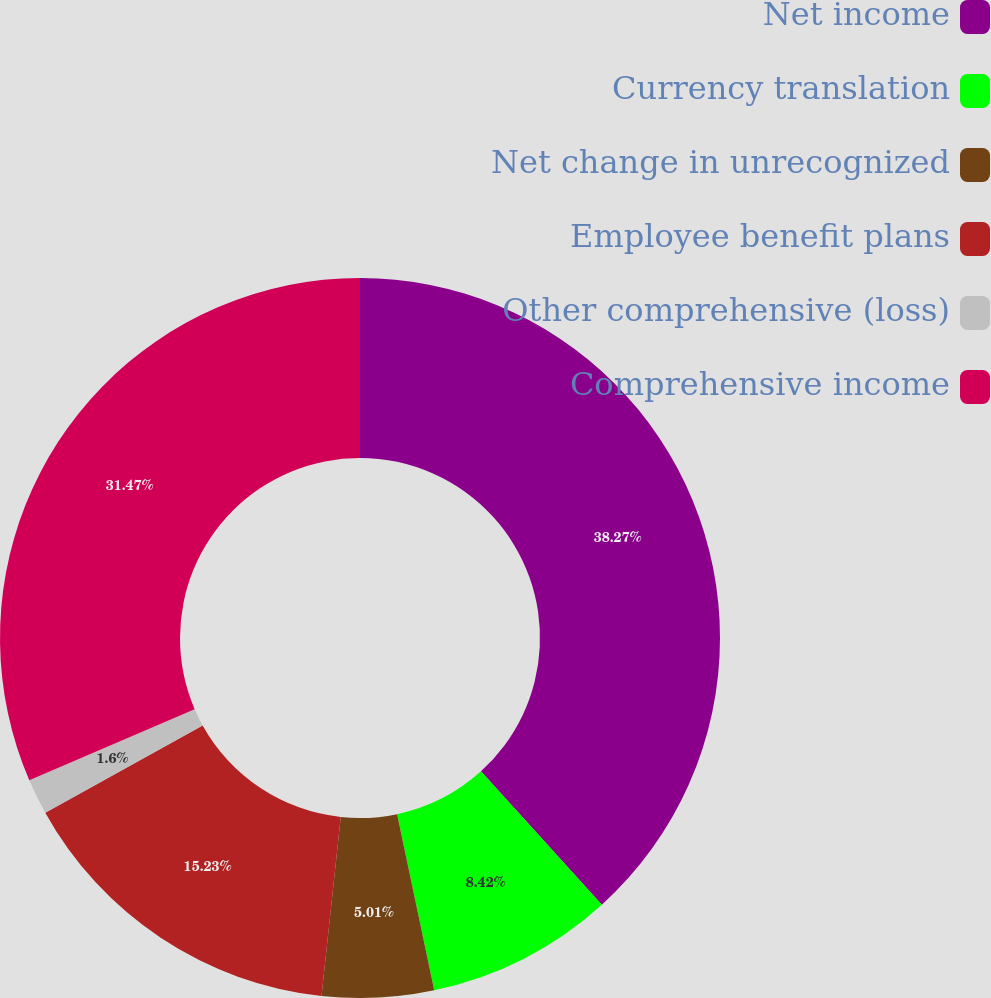Convert chart. <chart><loc_0><loc_0><loc_500><loc_500><pie_chart><fcel>Net income<fcel>Currency translation<fcel>Net change in unrecognized<fcel>Employee benefit plans<fcel>Other comprehensive (loss)<fcel>Comprehensive income<nl><fcel>38.28%<fcel>8.42%<fcel>5.01%<fcel>15.23%<fcel>1.6%<fcel>31.47%<nl></chart> 